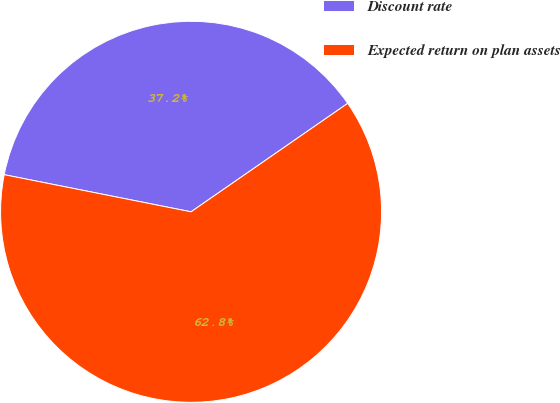<chart> <loc_0><loc_0><loc_500><loc_500><pie_chart><fcel>Discount rate<fcel>Expected return on plan assets<nl><fcel>37.24%<fcel>62.76%<nl></chart> 